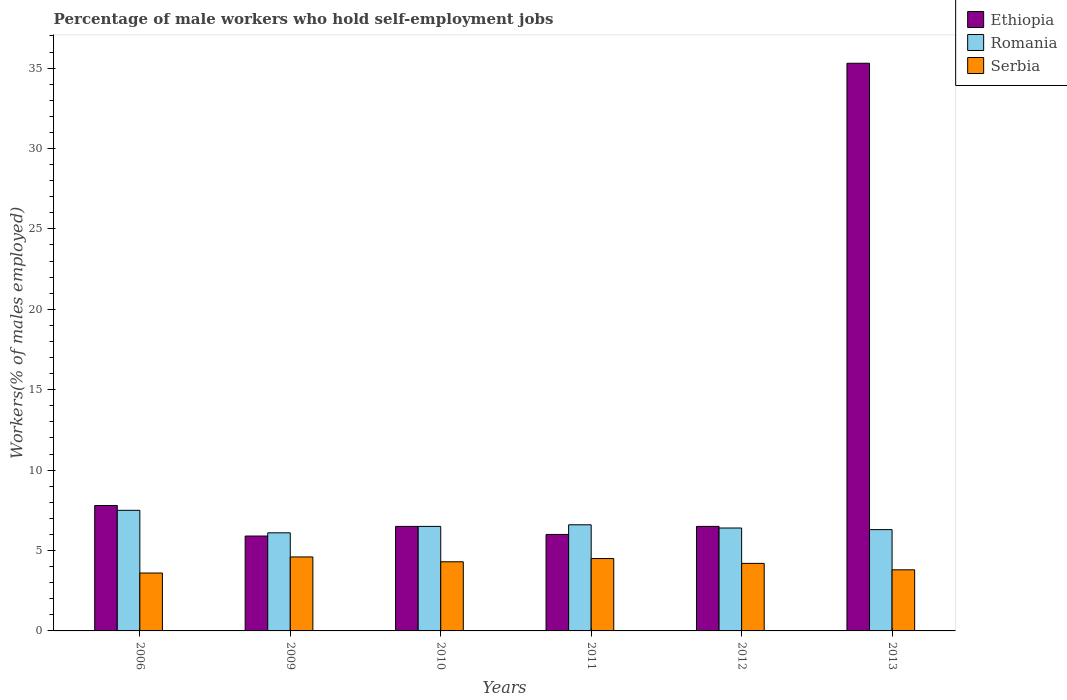Are the number of bars on each tick of the X-axis equal?
Ensure brevity in your answer.  Yes. How many bars are there on the 6th tick from the right?
Offer a terse response. 3. What is the label of the 6th group of bars from the left?
Provide a succinct answer. 2013. In how many cases, is the number of bars for a given year not equal to the number of legend labels?
Ensure brevity in your answer.  0. What is the percentage of self-employed male workers in Ethiopia in 2006?
Your answer should be compact. 7.8. Across all years, what is the maximum percentage of self-employed male workers in Ethiopia?
Give a very brief answer. 35.3. Across all years, what is the minimum percentage of self-employed male workers in Romania?
Your answer should be very brief. 6.1. What is the total percentage of self-employed male workers in Romania in the graph?
Your answer should be very brief. 39.4. What is the difference between the percentage of self-employed male workers in Serbia in 2010 and the percentage of self-employed male workers in Romania in 2006?
Provide a succinct answer. -3.2. What is the average percentage of self-employed male workers in Serbia per year?
Offer a terse response. 4.17. In the year 2012, what is the difference between the percentage of self-employed male workers in Romania and percentage of self-employed male workers in Ethiopia?
Keep it short and to the point. -0.1. In how many years, is the percentage of self-employed male workers in Serbia greater than 14 %?
Your response must be concise. 0. What is the ratio of the percentage of self-employed male workers in Serbia in 2006 to that in 2012?
Keep it short and to the point. 0.86. Is the percentage of self-employed male workers in Ethiopia in 2010 less than that in 2013?
Provide a short and direct response. Yes. What is the difference between the highest and the second highest percentage of self-employed male workers in Serbia?
Provide a succinct answer. 0.1. What is the difference between the highest and the lowest percentage of self-employed male workers in Romania?
Your answer should be compact. 1.4. In how many years, is the percentage of self-employed male workers in Serbia greater than the average percentage of self-employed male workers in Serbia taken over all years?
Give a very brief answer. 4. Is the sum of the percentage of self-employed male workers in Ethiopia in 2006 and 2011 greater than the maximum percentage of self-employed male workers in Serbia across all years?
Provide a succinct answer. Yes. What does the 1st bar from the left in 2010 represents?
Provide a short and direct response. Ethiopia. What does the 1st bar from the right in 2010 represents?
Your response must be concise. Serbia. How many bars are there?
Offer a terse response. 18. How many years are there in the graph?
Ensure brevity in your answer.  6. What is the difference between two consecutive major ticks on the Y-axis?
Ensure brevity in your answer.  5. Does the graph contain grids?
Provide a short and direct response. No. Where does the legend appear in the graph?
Provide a succinct answer. Top right. How many legend labels are there?
Keep it short and to the point. 3. What is the title of the graph?
Offer a very short reply. Percentage of male workers who hold self-employment jobs. Does "Northern Mariana Islands" appear as one of the legend labels in the graph?
Give a very brief answer. No. What is the label or title of the Y-axis?
Offer a terse response. Workers(% of males employed). What is the Workers(% of males employed) in Ethiopia in 2006?
Offer a terse response. 7.8. What is the Workers(% of males employed) of Serbia in 2006?
Give a very brief answer. 3.6. What is the Workers(% of males employed) in Ethiopia in 2009?
Offer a terse response. 5.9. What is the Workers(% of males employed) of Romania in 2009?
Provide a short and direct response. 6.1. What is the Workers(% of males employed) in Serbia in 2009?
Your answer should be compact. 4.6. What is the Workers(% of males employed) of Ethiopia in 2010?
Your answer should be very brief. 6.5. What is the Workers(% of males employed) in Romania in 2010?
Make the answer very short. 6.5. What is the Workers(% of males employed) of Serbia in 2010?
Provide a short and direct response. 4.3. What is the Workers(% of males employed) of Ethiopia in 2011?
Your answer should be compact. 6. What is the Workers(% of males employed) of Romania in 2011?
Keep it short and to the point. 6.6. What is the Workers(% of males employed) in Serbia in 2011?
Keep it short and to the point. 4.5. What is the Workers(% of males employed) in Romania in 2012?
Make the answer very short. 6.4. What is the Workers(% of males employed) in Serbia in 2012?
Make the answer very short. 4.2. What is the Workers(% of males employed) in Ethiopia in 2013?
Give a very brief answer. 35.3. What is the Workers(% of males employed) in Romania in 2013?
Keep it short and to the point. 6.3. What is the Workers(% of males employed) in Serbia in 2013?
Your answer should be compact. 3.8. Across all years, what is the maximum Workers(% of males employed) of Ethiopia?
Ensure brevity in your answer.  35.3. Across all years, what is the maximum Workers(% of males employed) of Serbia?
Make the answer very short. 4.6. Across all years, what is the minimum Workers(% of males employed) in Ethiopia?
Your response must be concise. 5.9. Across all years, what is the minimum Workers(% of males employed) in Romania?
Make the answer very short. 6.1. Across all years, what is the minimum Workers(% of males employed) of Serbia?
Make the answer very short. 3.6. What is the total Workers(% of males employed) of Romania in the graph?
Make the answer very short. 39.4. What is the difference between the Workers(% of males employed) in Romania in 2006 and that in 2009?
Offer a very short reply. 1.4. What is the difference between the Workers(% of males employed) of Ethiopia in 2006 and that in 2010?
Ensure brevity in your answer.  1.3. What is the difference between the Workers(% of males employed) in Romania in 2006 and that in 2010?
Offer a terse response. 1. What is the difference between the Workers(% of males employed) in Serbia in 2006 and that in 2010?
Offer a very short reply. -0.7. What is the difference between the Workers(% of males employed) of Ethiopia in 2006 and that in 2011?
Keep it short and to the point. 1.8. What is the difference between the Workers(% of males employed) in Serbia in 2006 and that in 2011?
Offer a very short reply. -0.9. What is the difference between the Workers(% of males employed) in Ethiopia in 2006 and that in 2012?
Offer a terse response. 1.3. What is the difference between the Workers(% of males employed) in Romania in 2006 and that in 2012?
Offer a terse response. 1.1. What is the difference between the Workers(% of males employed) of Serbia in 2006 and that in 2012?
Your response must be concise. -0.6. What is the difference between the Workers(% of males employed) of Ethiopia in 2006 and that in 2013?
Offer a terse response. -27.5. What is the difference between the Workers(% of males employed) in Ethiopia in 2009 and that in 2010?
Give a very brief answer. -0.6. What is the difference between the Workers(% of males employed) of Romania in 2009 and that in 2010?
Ensure brevity in your answer.  -0.4. What is the difference between the Workers(% of males employed) of Serbia in 2009 and that in 2010?
Offer a very short reply. 0.3. What is the difference between the Workers(% of males employed) in Romania in 2009 and that in 2011?
Ensure brevity in your answer.  -0.5. What is the difference between the Workers(% of males employed) of Serbia in 2009 and that in 2011?
Your response must be concise. 0.1. What is the difference between the Workers(% of males employed) in Romania in 2009 and that in 2012?
Your answer should be compact. -0.3. What is the difference between the Workers(% of males employed) of Serbia in 2009 and that in 2012?
Provide a succinct answer. 0.4. What is the difference between the Workers(% of males employed) in Ethiopia in 2009 and that in 2013?
Provide a short and direct response. -29.4. What is the difference between the Workers(% of males employed) in Romania in 2009 and that in 2013?
Offer a very short reply. -0.2. What is the difference between the Workers(% of males employed) in Serbia in 2009 and that in 2013?
Offer a very short reply. 0.8. What is the difference between the Workers(% of males employed) of Ethiopia in 2010 and that in 2011?
Make the answer very short. 0.5. What is the difference between the Workers(% of males employed) in Romania in 2010 and that in 2011?
Keep it short and to the point. -0.1. What is the difference between the Workers(% of males employed) of Romania in 2010 and that in 2012?
Keep it short and to the point. 0.1. What is the difference between the Workers(% of males employed) in Ethiopia in 2010 and that in 2013?
Provide a succinct answer. -28.8. What is the difference between the Workers(% of males employed) of Serbia in 2011 and that in 2012?
Give a very brief answer. 0.3. What is the difference between the Workers(% of males employed) in Ethiopia in 2011 and that in 2013?
Your answer should be compact. -29.3. What is the difference between the Workers(% of males employed) of Ethiopia in 2012 and that in 2013?
Ensure brevity in your answer.  -28.8. What is the difference between the Workers(% of males employed) of Ethiopia in 2006 and the Workers(% of males employed) of Serbia in 2010?
Offer a terse response. 3.5. What is the difference between the Workers(% of males employed) in Ethiopia in 2006 and the Workers(% of males employed) in Romania in 2011?
Your answer should be compact. 1.2. What is the difference between the Workers(% of males employed) in Ethiopia in 2006 and the Workers(% of males employed) in Serbia in 2011?
Make the answer very short. 3.3. What is the difference between the Workers(% of males employed) of Romania in 2006 and the Workers(% of males employed) of Serbia in 2011?
Your answer should be compact. 3. What is the difference between the Workers(% of males employed) in Romania in 2006 and the Workers(% of males employed) in Serbia in 2012?
Keep it short and to the point. 3.3. What is the difference between the Workers(% of males employed) of Ethiopia in 2009 and the Workers(% of males employed) of Romania in 2010?
Give a very brief answer. -0.6. What is the difference between the Workers(% of males employed) in Romania in 2009 and the Workers(% of males employed) in Serbia in 2010?
Provide a succinct answer. 1.8. What is the difference between the Workers(% of males employed) of Ethiopia in 2009 and the Workers(% of males employed) of Romania in 2011?
Your answer should be compact. -0.7. What is the difference between the Workers(% of males employed) of Ethiopia in 2009 and the Workers(% of males employed) of Romania in 2013?
Ensure brevity in your answer.  -0.4. What is the difference between the Workers(% of males employed) of Ethiopia in 2009 and the Workers(% of males employed) of Serbia in 2013?
Make the answer very short. 2.1. What is the difference between the Workers(% of males employed) in Romania in 2009 and the Workers(% of males employed) in Serbia in 2013?
Your answer should be compact. 2.3. What is the difference between the Workers(% of males employed) of Ethiopia in 2010 and the Workers(% of males employed) of Romania in 2011?
Provide a succinct answer. -0.1. What is the difference between the Workers(% of males employed) of Ethiopia in 2010 and the Workers(% of males employed) of Romania in 2012?
Make the answer very short. 0.1. What is the difference between the Workers(% of males employed) in Ethiopia in 2010 and the Workers(% of males employed) in Serbia in 2012?
Your response must be concise. 2.3. What is the difference between the Workers(% of males employed) of Ethiopia in 2010 and the Workers(% of males employed) of Romania in 2013?
Your response must be concise. 0.2. What is the difference between the Workers(% of males employed) in Ethiopia in 2010 and the Workers(% of males employed) in Serbia in 2013?
Provide a short and direct response. 2.7. What is the difference between the Workers(% of males employed) of Romania in 2010 and the Workers(% of males employed) of Serbia in 2013?
Provide a short and direct response. 2.7. What is the difference between the Workers(% of males employed) in Romania in 2011 and the Workers(% of males employed) in Serbia in 2013?
Ensure brevity in your answer.  2.8. What is the average Workers(% of males employed) in Ethiopia per year?
Your response must be concise. 11.33. What is the average Workers(% of males employed) of Romania per year?
Offer a terse response. 6.57. What is the average Workers(% of males employed) of Serbia per year?
Give a very brief answer. 4.17. In the year 2009, what is the difference between the Workers(% of males employed) of Ethiopia and Workers(% of males employed) of Serbia?
Your response must be concise. 1.3. In the year 2010, what is the difference between the Workers(% of males employed) of Romania and Workers(% of males employed) of Serbia?
Your answer should be compact. 2.2. In the year 2013, what is the difference between the Workers(% of males employed) in Ethiopia and Workers(% of males employed) in Romania?
Make the answer very short. 29. In the year 2013, what is the difference between the Workers(% of males employed) of Ethiopia and Workers(% of males employed) of Serbia?
Make the answer very short. 31.5. What is the ratio of the Workers(% of males employed) in Ethiopia in 2006 to that in 2009?
Offer a very short reply. 1.32. What is the ratio of the Workers(% of males employed) in Romania in 2006 to that in 2009?
Ensure brevity in your answer.  1.23. What is the ratio of the Workers(% of males employed) of Serbia in 2006 to that in 2009?
Provide a short and direct response. 0.78. What is the ratio of the Workers(% of males employed) in Romania in 2006 to that in 2010?
Your answer should be very brief. 1.15. What is the ratio of the Workers(% of males employed) in Serbia in 2006 to that in 2010?
Make the answer very short. 0.84. What is the ratio of the Workers(% of males employed) of Romania in 2006 to that in 2011?
Your response must be concise. 1.14. What is the ratio of the Workers(% of males employed) of Serbia in 2006 to that in 2011?
Offer a terse response. 0.8. What is the ratio of the Workers(% of males employed) in Romania in 2006 to that in 2012?
Make the answer very short. 1.17. What is the ratio of the Workers(% of males employed) of Ethiopia in 2006 to that in 2013?
Your answer should be very brief. 0.22. What is the ratio of the Workers(% of males employed) in Romania in 2006 to that in 2013?
Offer a terse response. 1.19. What is the ratio of the Workers(% of males employed) of Ethiopia in 2009 to that in 2010?
Provide a short and direct response. 0.91. What is the ratio of the Workers(% of males employed) in Romania in 2009 to that in 2010?
Give a very brief answer. 0.94. What is the ratio of the Workers(% of males employed) in Serbia in 2009 to that in 2010?
Offer a very short reply. 1.07. What is the ratio of the Workers(% of males employed) in Ethiopia in 2009 to that in 2011?
Keep it short and to the point. 0.98. What is the ratio of the Workers(% of males employed) in Romania in 2009 to that in 2011?
Provide a succinct answer. 0.92. What is the ratio of the Workers(% of males employed) in Serbia in 2009 to that in 2011?
Ensure brevity in your answer.  1.02. What is the ratio of the Workers(% of males employed) of Ethiopia in 2009 to that in 2012?
Give a very brief answer. 0.91. What is the ratio of the Workers(% of males employed) in Romania in 2009 to that in 2012?
Keep it short and to the point. 0.95. What is the ratio of the Workers(% of males employed) of Serbia in 2009 to that in 2012?
Your answer should be compact. 1.1. What is the ratio of the Workers(% of males employed) of Ethiopia in 2009 to that in 2013?
Give a very brief answer. 0.17. What is the ratio of the Workers(% of males employed) of Romania in 2009 to that in 2013?
Your answer should be compact. 0.97. What is the ratio of the Workers(% of males employed) of Serbia in 2009 to that in 2013?
Offer a very short reply. 1.21. What is the ratio of the Workers(% of males employed) of Ethiopia in 2010 to that in 2011?
Offer a terse response. 1.08. What is the ratio of the Workers(% of males employed) of Romania in 2010 to that in 2011?
Ensure brevity in your answer.  0.98. What is the ratio of the Workers(% of males employed) in Serbia in 2010 to that in 2011?
Provide a succinct answer. 0.96. What is the ratio of the Workers(% of males employed) of Romania in 2010 to that in 2012?
Your response must be concise. 1.02. What is the ratio of the Workers(% of males employed) in Serbia in 2010 to that in 2012?
Your answer should be very brief. 1.02. What is the ratio of the Workers(% of males employed) in Ethiopia in 2010 to that in 2013?
Provide a succinct answer. 0.18. What is the ratio of the Workers(% of males employed) in Romania in 2010 to that in 2013?
Ensure brevity in your answer.  1.03. What is the ratio of the Workers(% of males employed) of Serbia in 2010 to that in 2013?
Give a very brief answer. 1.13. What is the ratio of the Workers(% of males employed) of Romania in 2011 to that in 2012?
Your response must be concise. 1.03. What is the ratio of the Workers(% of males employed) of Serbia in 2011 to that in 2012?
Make the answer very short. 1.07. What is the ratio of the Workers(% of males employed) of Ethiopia in 2011 to that in 2013?
Give a very brief answer. 0.17. What is the ratio of the Workers(% of males employed) of Romania in 2011 to that in 2013?
Provide a short and direct response. 1.05. What is the ratio of the Workers(% of males employed) of Serbia in 2011 to that in 2013?
Offer a terse response. 1.18. What is the ratio of the Workers(% of males employed) in Ethiopia in 2012 to that in 2013?
Give a very brief answer. 0.18. What is the ratio of the Workers(% of males employed) of Romania in 2012 to that in 2013?
Make the answer very short. 1.02. What is the ratio of the Workers(% of males employed) of Serbia in 2012 to that in 2013?
Offer a very short reply. 1.11. What is the difference between the highest and the second highest Workers(% of males employed) of Ethiopia?
Your response must be concise. 27.5. What is the difference between the highest and the lowest Workers(% of males employed) in Ethiopia?
Your response must be concise. 29.4. What is the difference between the highest and the lowest Workers(% of males employed) of Serbia?
Your answer should be compact. 1. 